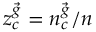Convert formula to latex. <formula><loc_0><loc_0><loc_500><loc_500>z _ { c } ^ { \vec { g } } = n _ { c } ^ { \vec { g } } / n</formula> 